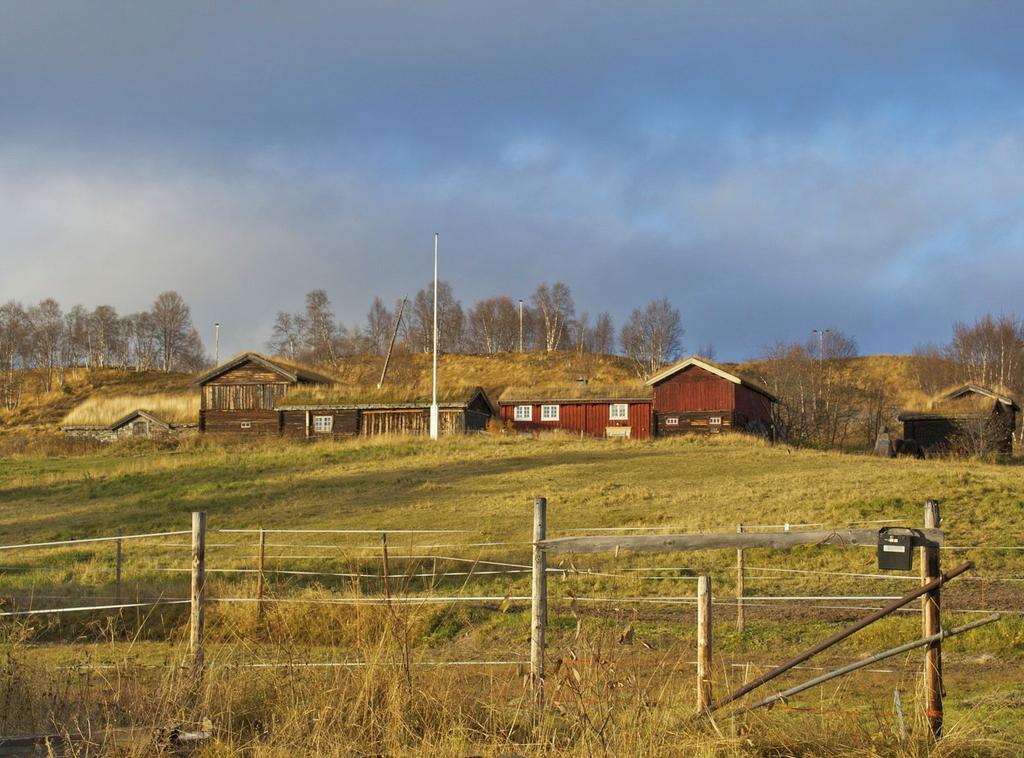Can you describe this image briefly? In this picture we can see fence and grass, in the background we can see few houses, trees and poles. 